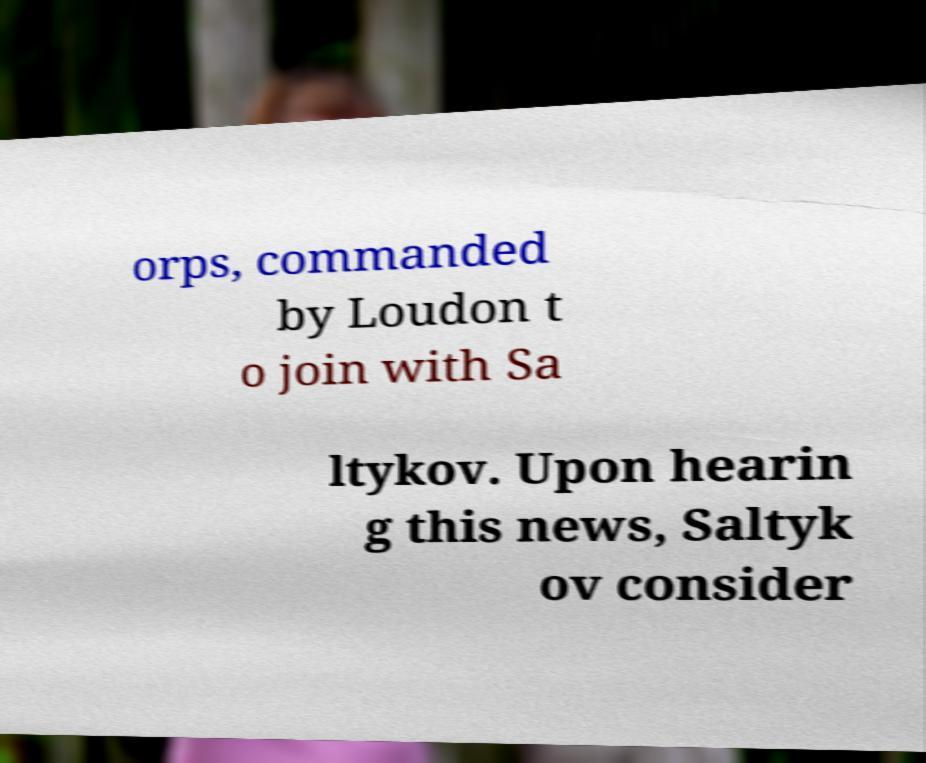For documentation purposes, I need the text within this image transcribed. Could you provide that? orps, commanded by Loudon t o join with Sa ltykov. Upon hearin g this news, Saltyk ov consider 